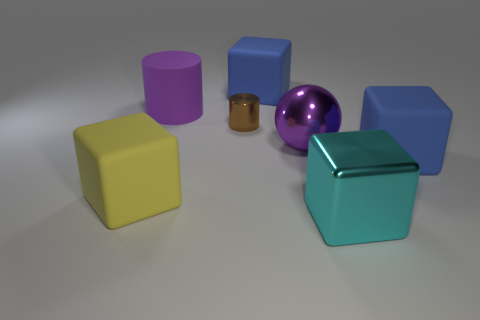Add 3 brown shiny objects. How many objects exist? 10 Subtract all cubes. How many objects are left? 3 Subtract all large yellow rubber blocks. Subtract all purple spheres. How many objects are left? 5 Add 1 large cylinders. How many large cylinders are left? 2 Add 1 big cyan shiny objects. How many big cyan shiny objects exist? 2 Subtract 1 purple cylinders. How many objects are left? 6 